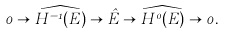<formula> <loc_0><loc_0><loc_500><loc_500>0 \to \widehat { H ^ { - 1 } ( E ) } \to \hat { E } \to \widehat { H ^ { 0 } ( E ) } \to 0 .</formula> 